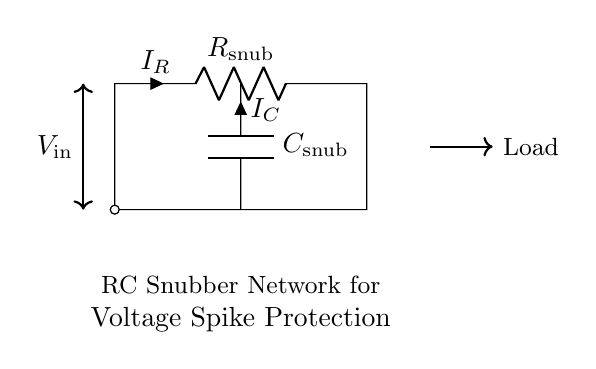What is the type of the circuit? The circuit is an RC snubber network, which consists of a resistor and a capacitor used to suppress voltage spikes.
Answer: RC snubber network What does the capacitor in the circuit do? The capacitor stores energy temporarily and helps absorb voltage spikes, protecting the circuit components downstream.
Answer: Absorb voltage spikes What is the symbol for the resistor in the diagram? The symbol for the resistor in the diagram is represented as a zigzag line, which is the standard notation for resistors.
Answer: Zigzag line What are the labels of the components in the circuit? The components are labelled as R snub for the resistor and C snub for the capacitor, indicating their roles in the snubber network.
Answer: R snub and C snub What is the current direction through the resistor? The current direction through the resistor is indicated by the arrow labelled I_R, which points into the top of the resistor.
Answer: Downward What is the purpose of the voltage label in the diagram? The voltage label indicates the potential difference across the circuit, specifically from V_in, which influences how the components react to voltage changes.
Answer: Potential difference How does the combination of R and C impact voltage spikes? The combination of R and C defines the time constant of the snubber, which helps determine how quickly the circuit responds to voltage spikes and mitigates them.
Answer: Defines time constant 